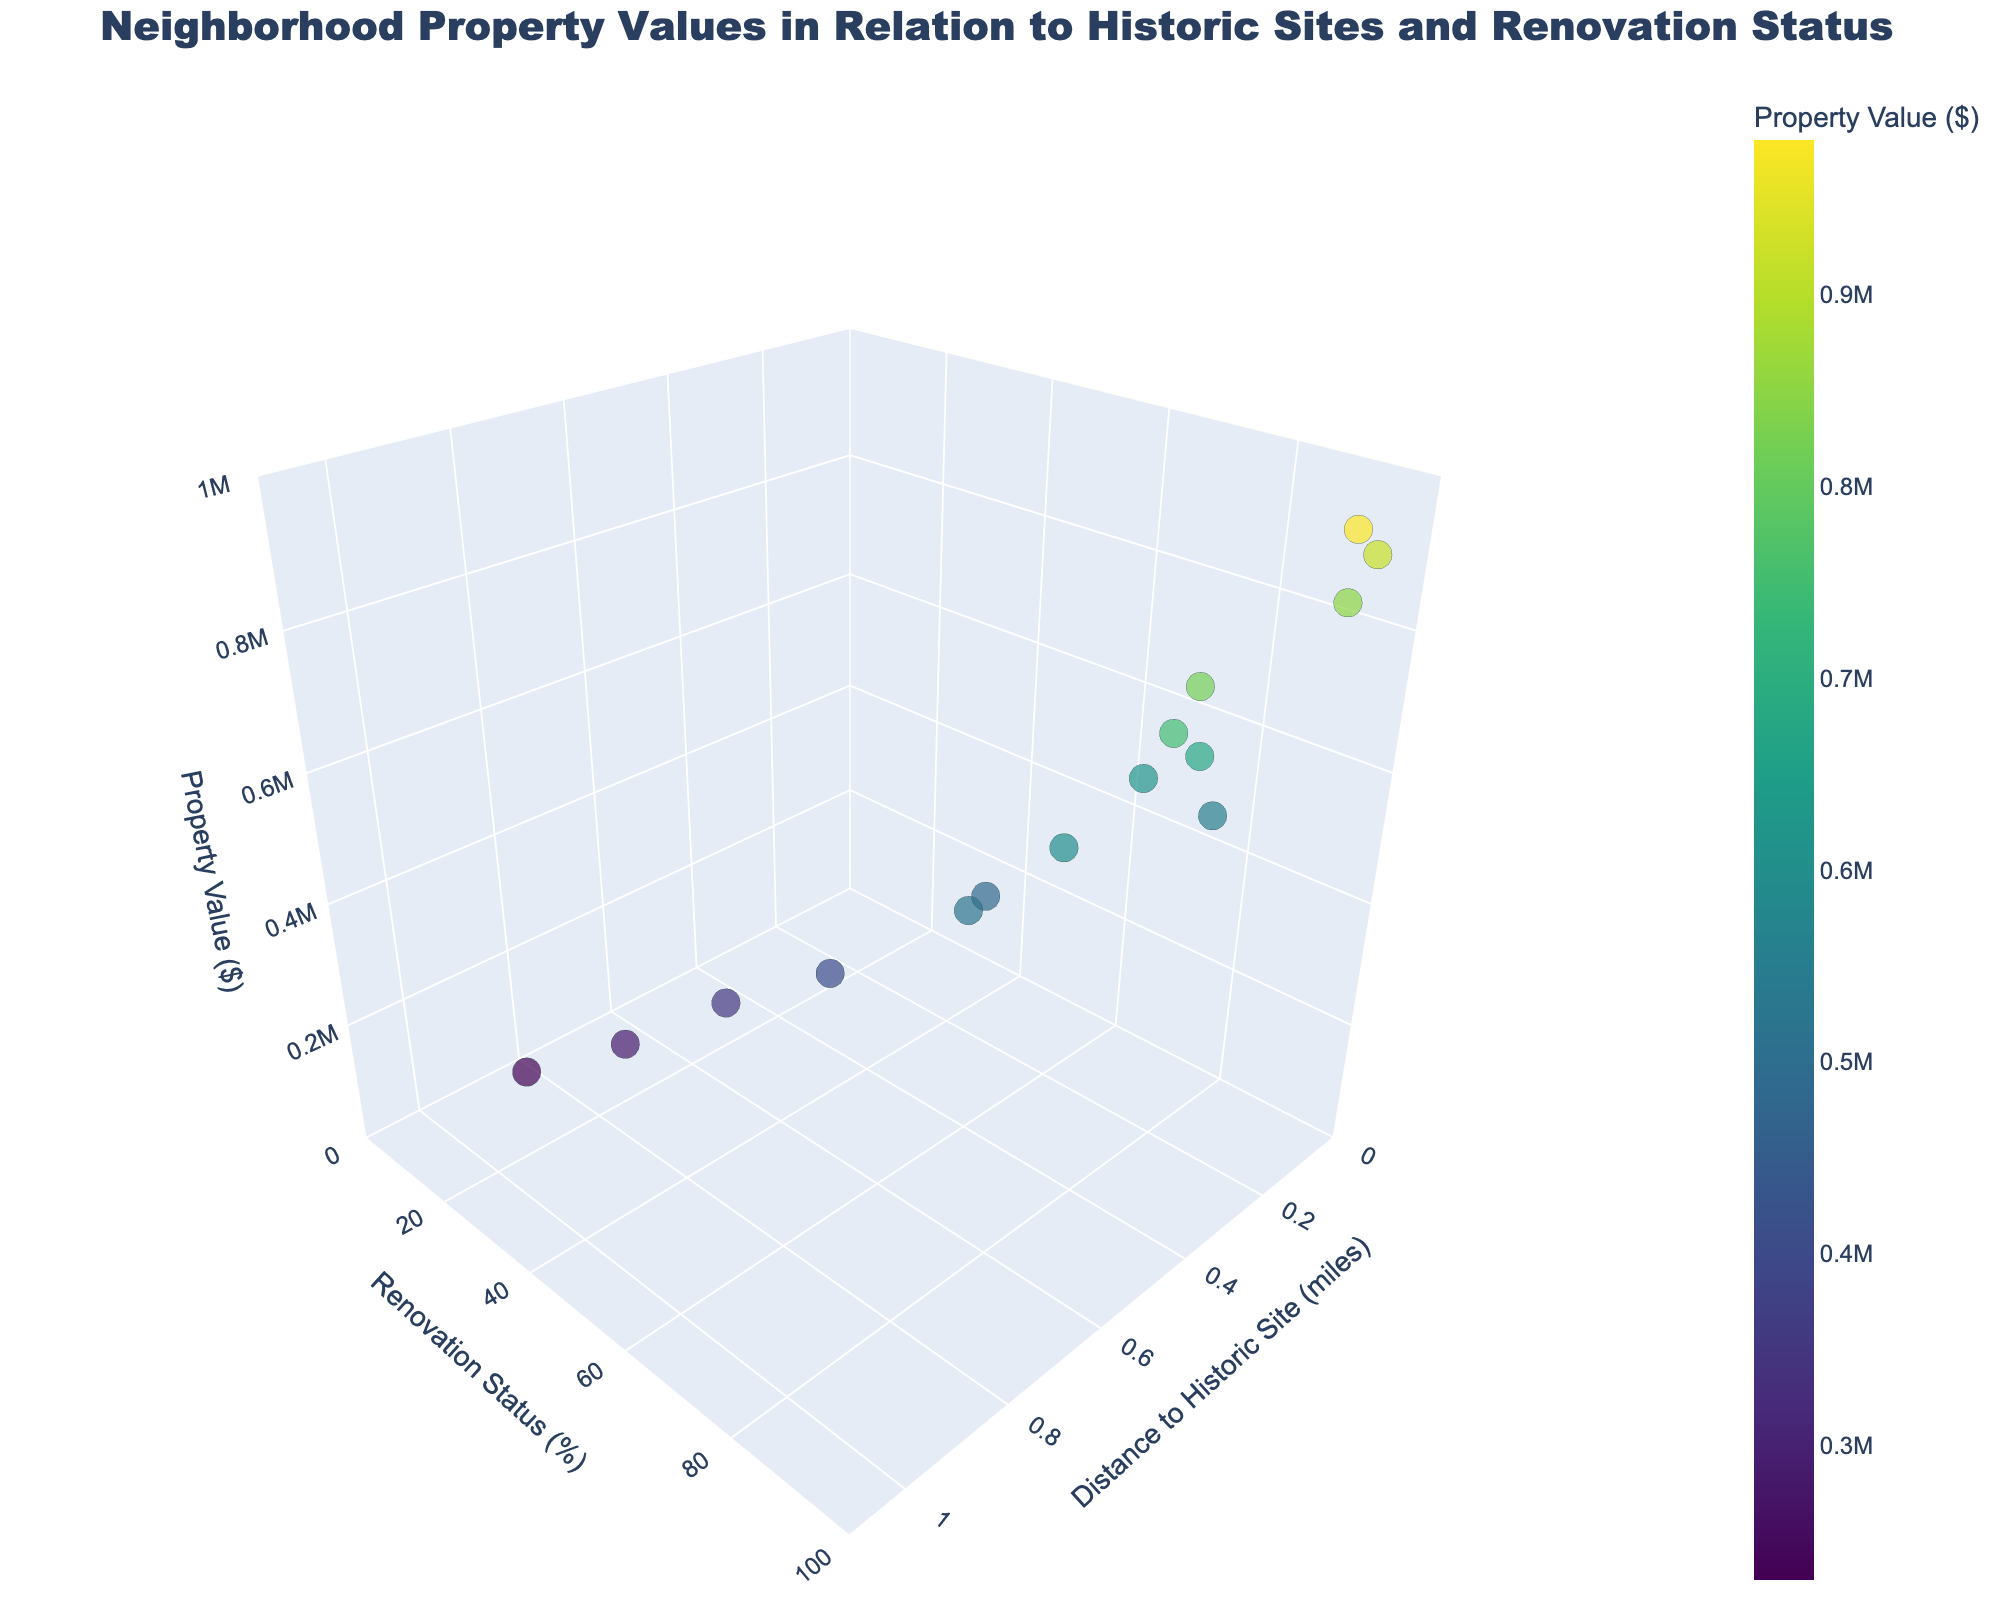How many data points are displayed in the plot? Counting the data points listed in the data (one for each property), there are a total of 15 points in the plot.
Answer: 15 Which property has the highest renovation status? By examining the 'RenovationStatus' axis, the property with the highest renovation status is the 'Beaux-Arts Building' with a status of 100%.
Answer: Beaux-Arts Building What's the average property value for properties within 0.5 miles of historic sites? The properties within 0.5 miles are: Victorian Mansion, Colonial Revival House, Tudor Revival Cottage, Queen Anne Villa, Beaux-Arts Building, Gothic Revival Church, and Second Empire Hotel. Summing their values: 850000 + 620000 + 550000 + 750000 + 980000 + 680000 + 820000 = 5250000. Dividing by the number of properties (7), the average is 5250000 / 7 ≈ 750000.
Answer: 750000 Which property is both closest to a historic site and has the highest value? The closest properties are Victorian Mansion and Neoclassical Mansion, both at 0.1 miles. Among these, Neoclassical Mansion has the higher value of 920000.
Answer: Neoclassical Mansion Do properties with higher renovation status generally have higher values? Examining the plot's trend, there appears to be a positive correlation between renovation status and property value, indicating that properties with higher renovation status often have higher values.
Answer: Yes Which property is the farthest from a historic site and what is its value? The farthest property is the Spanish Colonial Revival at 1.0 miles from a historic site, with a value of 230000.
Answer: Spanish Colonial Revival Comparing properties between 40% and 60% renovation status, which one has the highest value? Within 40% - 60% renovation status are Federal Style Residence (40%) and Greek Revival Home (60%). The property with the highest value among these is Greek Revival Home with 400000.
Answer: Greek Revival Home What is the range of property values shown in the plot? The lowest property value is 230000 (Spanish Colonial Revival) and the highest is 980000 (Beaux-Arts Building), so the range is 980000 - 230000 = 750000.
Answer: 750000 Are there more properties with renovation status above or below 50%? Counting the number of properties with renovation status >50%: 11 properties. Counting the number of properties with renovation status ≤50%: 4 properties. Thus, there are more properties with renovation status above 50%.
Answer: Above 50% Is there a correlation between distance to a historic site and property value? Observing the plot, it shows a tendency that properties closer to historic sites often have higher values, suggesting a negative correlation between distance to a historic site and property value.
Answer: Negative correlation 